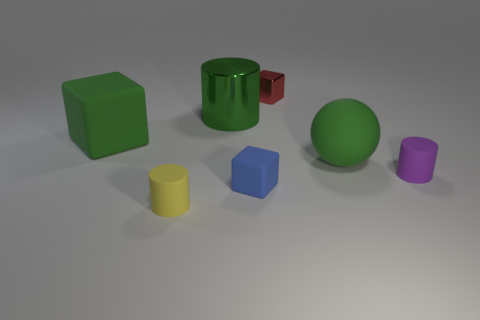What number of other rubber objects have the same shape as the purple object?
Keep it short and to the point. 1. Does the green thing right of the tiny red metal object have the same material as the red block?
Provide a short and direct response. No. Is the number of cylinders that are behind the purple cylinder the same as the number of purple matte objects behind the green metallic thing?
Provide a succinct answer. No. Is there any other thing that is the same size as the green metallic cylinder?
Offer a terse response. Yes. What is the material of the blue object that is the same shape as the red metal thing?
Ensure brevity in your answer.  Rubber. There is a big green cube that is on the left side of the matte cube in front of the big green matte ball; is there a yellow rubber object that is behind it?
Offer a very short reply. No. There is a matte object that is behind the big sphere; does it have the same shape as the green object that is right of the big cylinder?
Ensure brevity in your answer.  No. Is the number of green things on the right side of the red shiny object greater than the number of brown cylinders?
Your answer should be compact. Yes. How many things are big red matte cylinders or small cubes?
Provide a succinct answer. 2. What is the color of the big cylinder?
Your response must be concise. Green. 